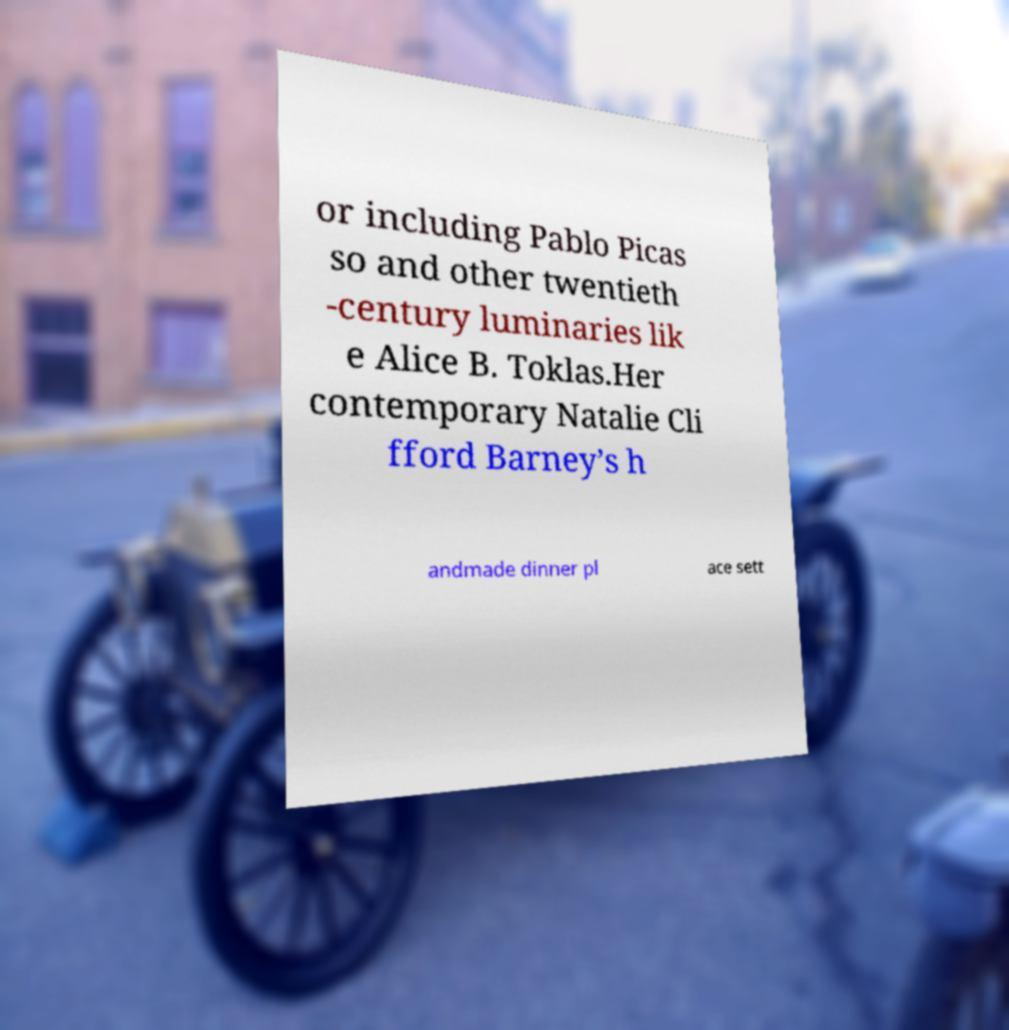Can you accurately transcribe the text from the provided image for me? or including Pablo Picas so and other twentieth -century luminaries lik e Alice B. Toklas.Her contemporary Natalie Cli fford Barney’s h andmade dinner pl ace sett 